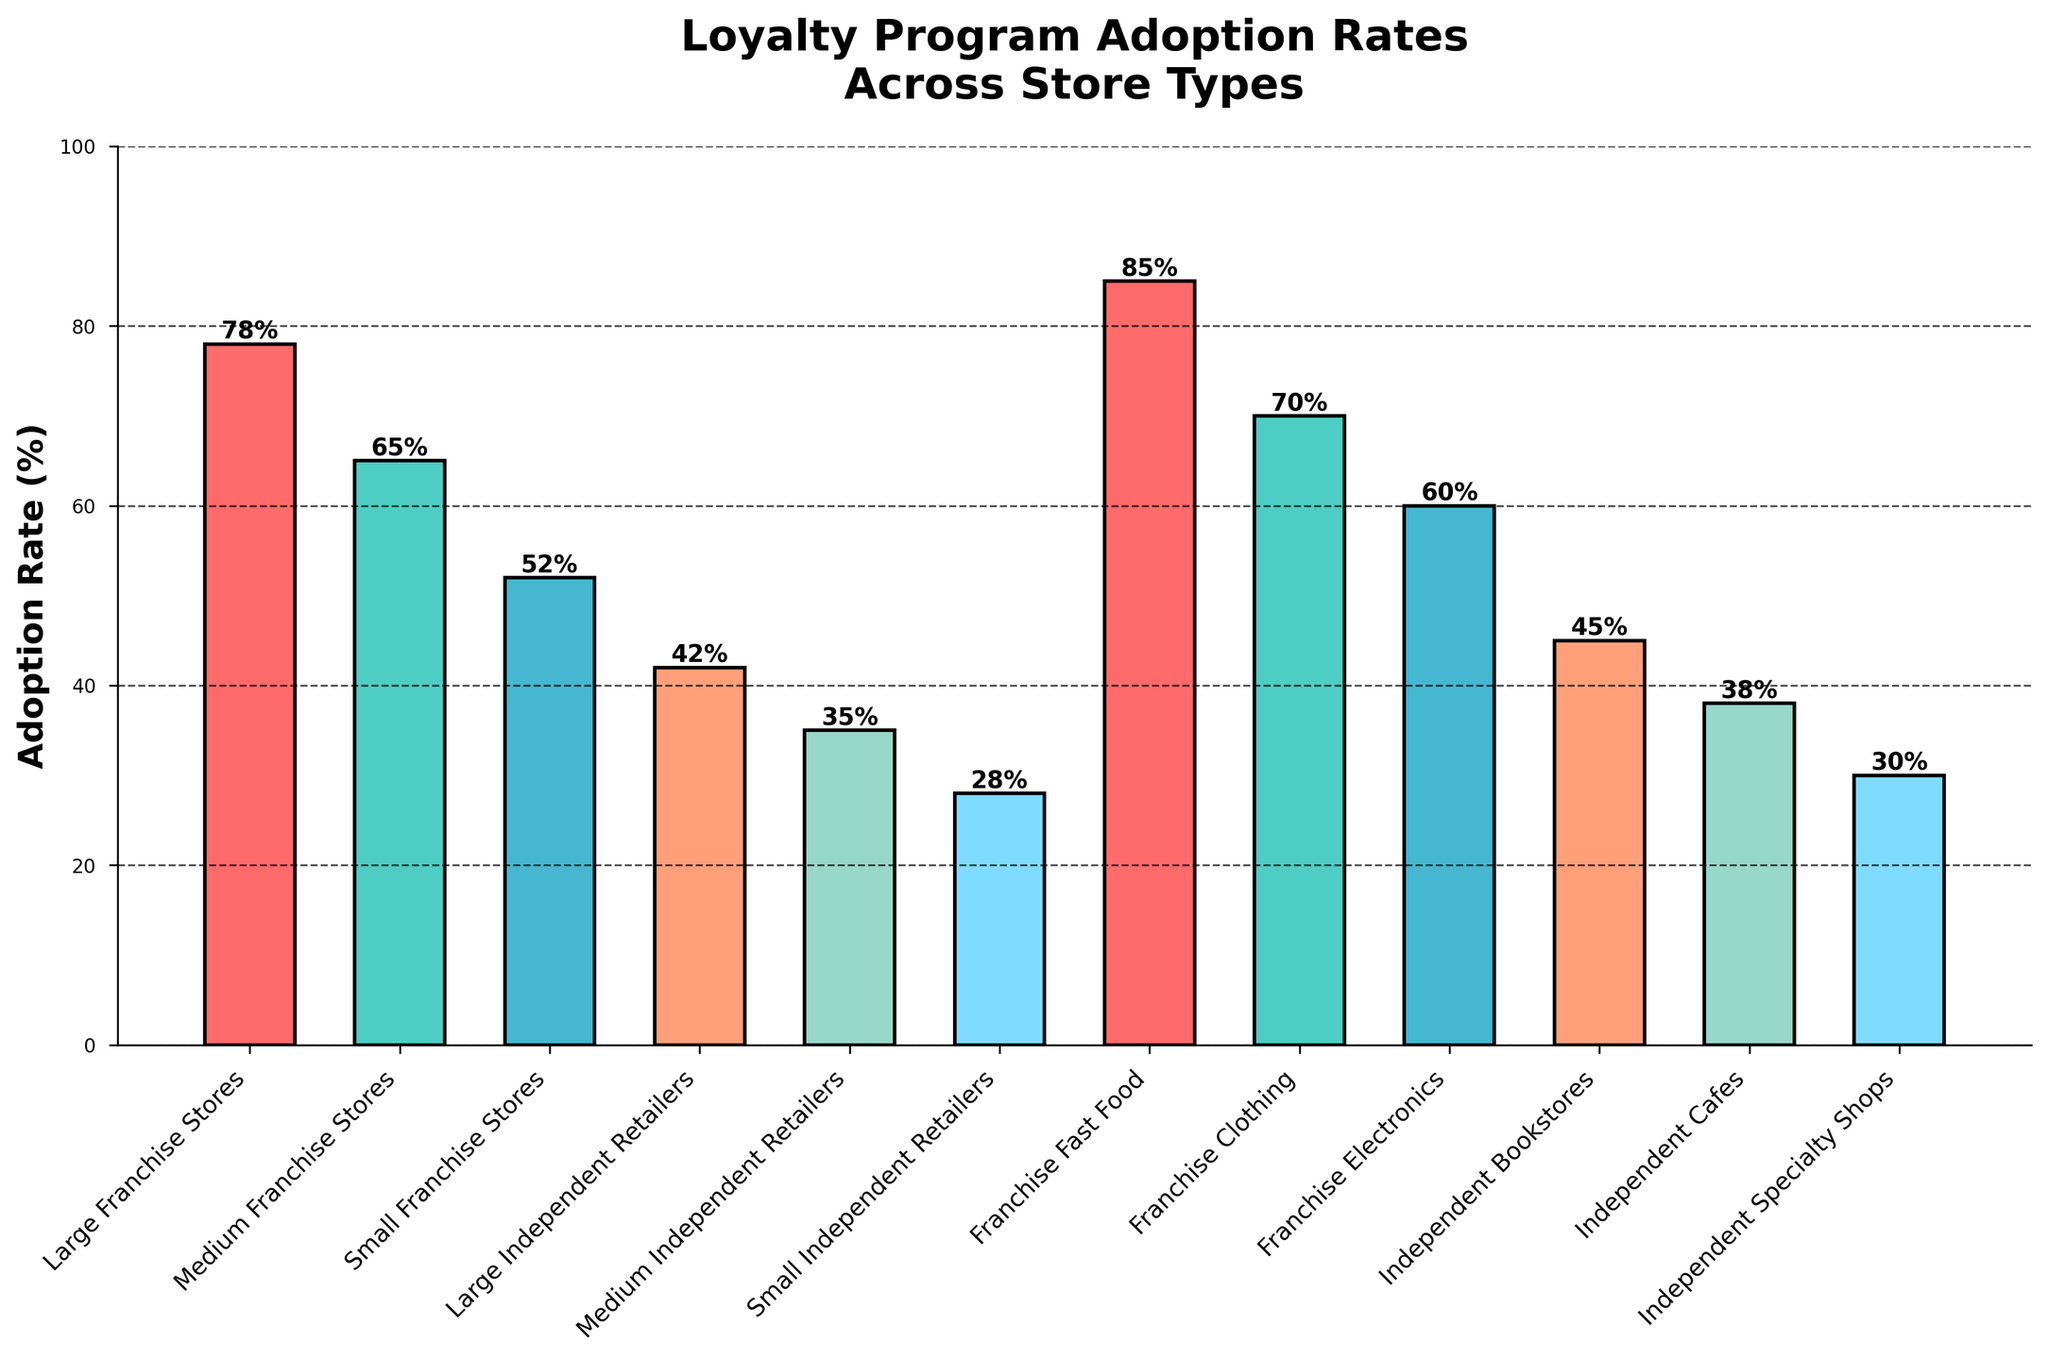Which store type has the highest loyalty program adoption rate? From the bar heights in the figure, the Franchise Fast Food store type has the tallest bar, indicating the highest adoption rate.
Answer: Franchise Fast Food How much higher is the adoption rate in Large Franchise Stores compared to Small Franchise Stores? The height of the bar for Large Franchise Stores is 78%, and for Small Franchise Stores, it is 52%. The difference between these is 78% - 52% = 26%.
Answer: 26% What's the combined adoption rate for all types of Independent Retailers? The adoption rates for Large, Medium, and Small Independent Retailers are 42%, 35%, and 28%, respectively. The combined rate is 42% + 35% + 28% = 105%.
Answer: 105% Which store type among independent retailers has the lowest adoption rate? Among independent retailers, Small Independent Retailers have the lowest adoption rate, as their bar is the shortest.
Answer: Small Independent Retailers Is the adoption rate of Franchise Electronics stores higher or lower than Independent Bookstores? Franchise Electronics stores have an adoption rate of 60%, while Independent Bookstores have 45%. Since 60% > 45%, the adoption rate is higher in Franchise Electronics stores.
Answer: higher What is the average adoption rate of Independent Cafes and Independent Specialty Shops? Independent Cafes have an adoption rate of 38%, and Independent Specialty Shops have 30%. The average is (38% + 30%) / 2 = 34%.
Answer: 34% Which has a greater adoption rate: Medium Franchise Stores or Franchise Clothing? Medium Franchise Stores have an adoption rate of 65%, while Franchise Clothing has 70%. Since 65% < 70%, Franchise Clothing has a greater adoption rate.
Answer: Franchise Clothing How does the adoption rate of Medium Independent Retailers compare to Large Independent Retailers? Medium Independent Retailers have an adoption rate of 35%, and Large Independent Retailers have 42%. Since 35% < 42%, Medium Independent Retailers have a lower adoption rate.
Answer: lower What is the total adoption rate percentage for all Franchise store categories? The adoption rates for Large, Medium, and Small Franchise Stores are 78%, 65%, and 52%, respectively. Adding these together: 78% + 65% + 52% = 195%.
Answer: 195% What is the difference in adoption rates between Franchise Fast Food and Small Independent Retailers? Franchise Fast Food has an adoption rate of 85%, and Small Independent Retailers have 28%. The difference is 85% - 28% = 57%.
Answer: 57% 